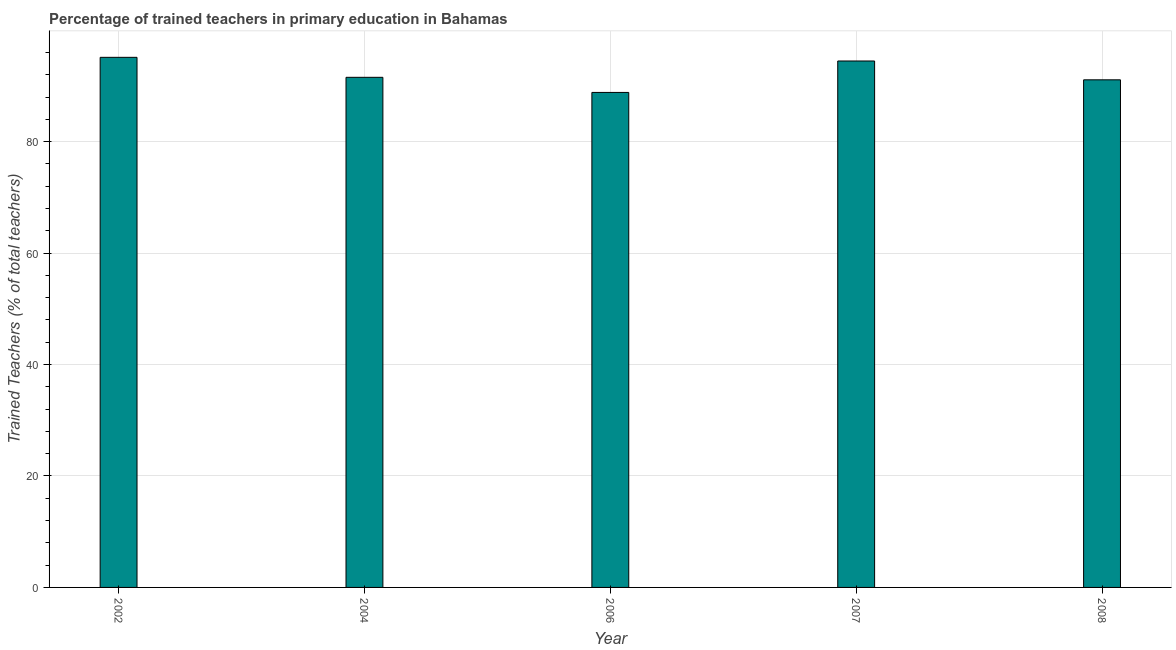Does the graph contain any zero values?
Provide a short and direct response. No. Does the graph contain grids?
Offer a very short reply. Yes. What is the title of the graph?
Provide a short and direct response. Percentage of trained teachers in primary education in Bahamas. What is the label or title of the Y-axis?
Your answer should be very brief. Trained Teachers (% of total teachers). What is the percentage of trained teachers in 2008?
Offer a very short reply. 91.08. Across all years, what is the maximum percentage of trained teachers?
Provide a short and direct response. 95.12. Across all years, what is the minimum percentage of trained teachers?
Ensure brevity in your answer.  88.82. In which year was the percentage of trained teachers maximum?
Give a very brief answer. 2002. In which year was the percentage of trained teachers minimum?
Keep it short and to the point. 2006. What is the sum of the percentage of trained teachers?
Give a very brief answer. 461.03. What is the difference between the percentage of trained teachers in 2004 and 2006?
Offer a terse response. 2.71. What is the average percentage of trained teachers per year?
Your answer should be very brief. 92.2. What is the median percentage of trained teachers?
Offer a very short reply. 91.53. Do a majority of the years between 2002 and 2008 (inclusive) have percentage of trained teachers greater than 20 %?
Provide a succinct answer. Yes. What is the ratio of the percentage of trained teachers in 2006 to that in 2008?
Make the answer very short. 0.97. Is the percentage of trained teachers in 2002 less than that in 2006?
Your response must be concise. No. What is the difference between the highest and the second highest percentage of trained teachers?
Your answer should be very brief. 0.66. In how many years, is the percentage of trained teachers greater than the average percentage of trained teachers taken over all years?
Offer a very short reply. 2. What is the difference between two consecutive major ticks on the Y-axis?
Provide a short and direct response. 20. What is the Trained Teachers (% of total teachers) in 2002?
Offer a very short reply. 95.12. What is the Trained Teachers (% of total teachers) in 2004?
Make the answer very short. 91.53. What is the Trained Teachers (% of total teachers) in 2006?
Offer a very short reply. 88.82. What is the Trained Teachers (% of total teachers) of 2007?
Provide a succinct answer. 94.46. What is the Trained Teachers (% of total teachers) of 2008?
Provide a succinct answer. 91.08. What is the difference between the Trained Teachers (% of total teachers) in 2002 and 2004?
Make the answer very short. 3.59. What is the difference between the Trained Teachers (% of total teachers) in 2002 and 2006?
Your answer should be compact. 6.3. What is the difference between the Trained Teachers (% of total teachers) in 2002 and 2007?
Your answer should be compact. 0.66. What is the difference between the Trained Teachers (% of total teachers) in 2002 and 2008?
Make the answer very short. 4.04. What is the difference between the Trained Teachers (% of total teachers) in 2004 and 2006?
Offer a terse response. 2.71. What is the difference between the Trained Teachers (% of total teachers) in 2004 and 2007?
Your answer should be compact. -2.93. What is the difference between the Trained Teachers (% of total teachers) in 2004 and 2008?
Offer a terse response. 0.45. What is the difference between the Trained Teachers (% of total teachers) in 2006 and 2007?
Keep it short and to the point. -5.64. What is the difference between the Trained Teachers (% of total teachers) in 2006 and 2008?
Make the answer very short. -2.26. What is the difference between the Trained Teachers (% of total teachers) in 2007 and 2008?
Keep it short and to the point. 3.38. What is the ratio of the Trained Teachers (% of total teachers) in 2002 to that in 2004?
Provide a short and direct response. 1.04. What is the ratio of the Trained Teachers (% of total teachers) in 2002 to that in 2006?
Provide a short and direct response. 1.07. What is the ratio of the Trained Teachers (% of total teachers) in 2002 to that in 2008?
Your answer should be very brief. 1.04. What is the ratio of the Trained Teachers (% of total teachers) in 2004 to that in 2006?
Your response must be concise. 1.03. What is the ratio of the Trained Teachers (% of total teachers) in 2004 to that in 2007?
Give a very brief answer. 0.97. What is the ratio of the Trained Teachers (% of total teachers) in 2004 to that in 2008?
Provide a short and direct response. 1. What is the ratio of the Trained Teachers (% of total teachers) in 2006 to that in 2008?
Make the answer very short. 0.97. What is the ratio of the Trained Teachers (% of total teachers) in 2007 to that in 2008?
Provide a succinct answer. 1.04. 